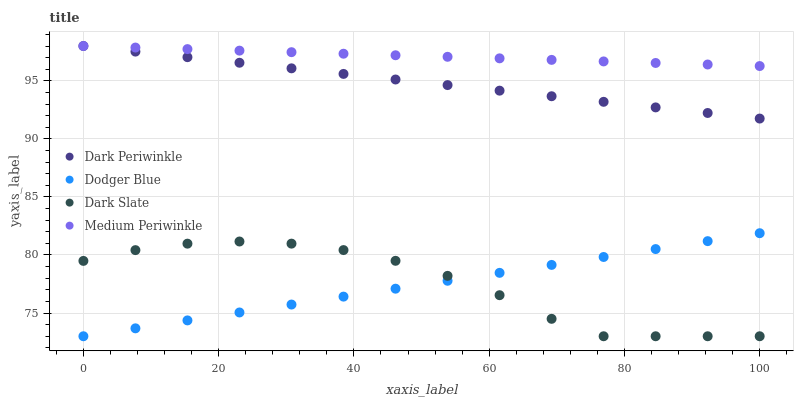Does Dodger Blue have the minimum area under the curve?
Answer yes or no. Yes. Does Medium Periwinkle have the maximum area under the curve?
Answer yes or no. Yes. Does Dark Periwinkle have the minimum area under the curve?
Answer yes or no. No. Does Dark Periwinkle have the maximum area under the curve?
Answer yes or no. No. Is Medium Periwinkle the smoothest?
Answer yes or no. Yes. Is Dark Slate the roughest?
Answer yes or no. Yes. Is Dodger Blue the smoothest?
Answer yes or no. No. Is Dodger Blue the roughest?
Answer yes or no. No. Does Dark Slate have the lowest value?
Answer yes or no. Yes. Does Dark Periwinkle have the lowest value?
Answer yes or no. No. Does Medium Periwinkle have the highest value?
Answer yes or no. Yes. Does Dodger Blue have the highest value?
Answer yes or no. No. Is Dodger Blue less than Dark Periwinkle?
Answer yes or no. Yes. Is Medium Periwinkle greater than Dodger Blue?
Answer yes or no. Yes. Does Dodger Blue intersect Dark Slate?
Answer yes or no. Yes. Is Dodger Blue less than Dark Slate?
Answer yes or no. No. Is Dodger Blue greater than Dark Slate?
Answer yes or no. No. Does Dodger Blue intersect Dark Periwinkle?
Answer yes or no. No. 